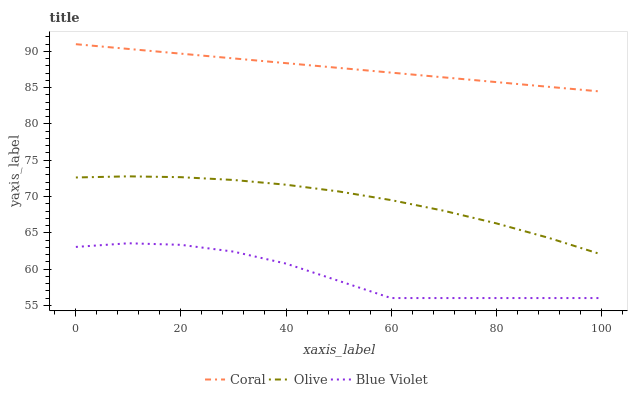Does Coral have the minimum area under the curve?
Answer yes or no. No. Does Blue Violet have the maximum area under the curve?
Answer yes or no. No. Is Blue Violet the smoothest?
Answer yes or no. No. Is Coral the roughest?
Answer yes or no. No. Does Coral have the lowest value?
Answer yes or no. No. Does Blue Violet have the highest value?
Answer yes or no. No. Is Blue Violet less than Olive?
Answer yes or no. Yes. Is Olive greater than Blue Violet?
Answer yes or no. Yes. Does Blue Violet intersect Olive?
Answer yes or no. No. 